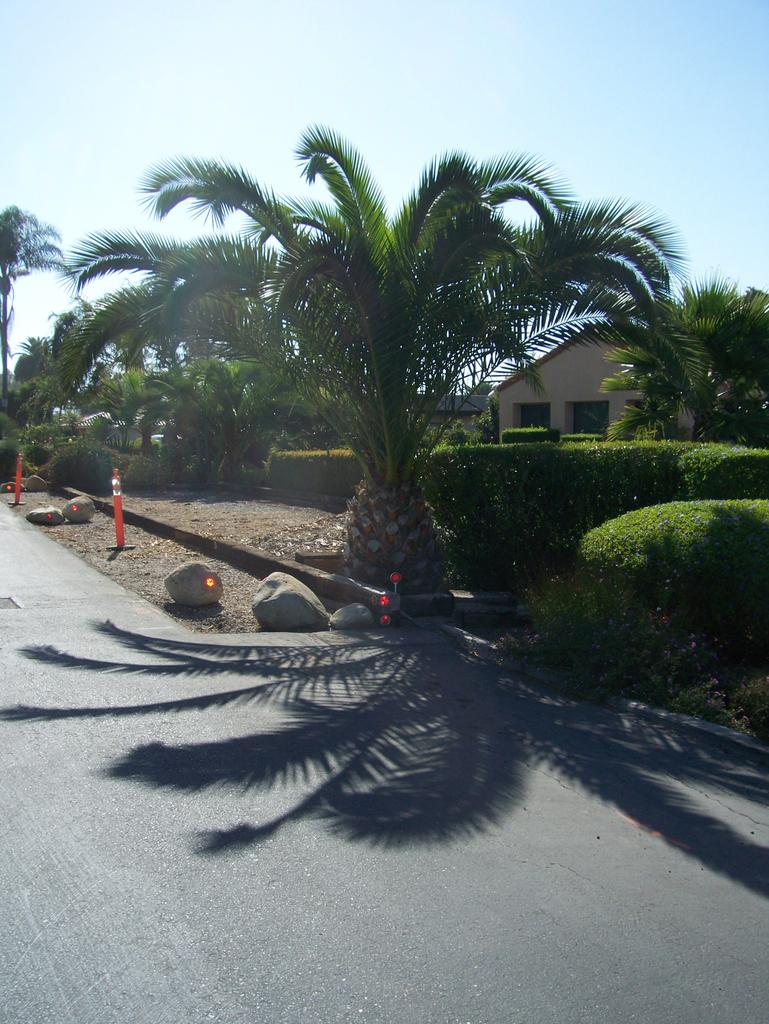What can be found on the road in the image? There are stones and poles on the road in the image. What is reflected on the road? There is a reflection of a tree on the road. What can be seen in the background of the image? There are trees and a house in the background of the image. Can you see a bike being ridden by someone in the image? There is no bike or person riding a bike present in the image. Is anyone wearing a mask in the image? There is no one wearing a mask in the image. 